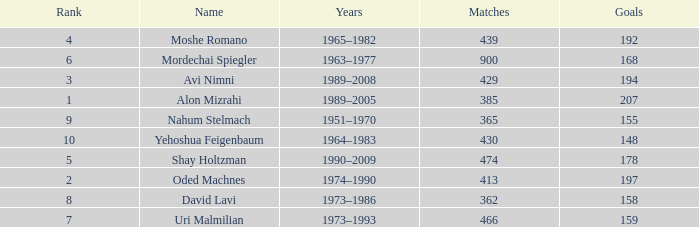What is the Rank of the player with 158 Goals in more than 362 Matches? 0.0. 